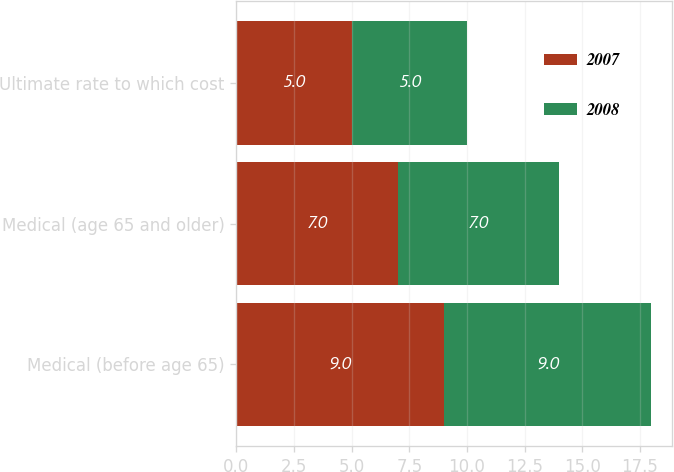Convert chart. <chart><loc_0><loc_0><loc_500><loc_500><stacked_bar_chart><ecel><fcel>Medical (before age 65)<fcel>Medical (age 65 and older)<fcel>Ultimate rate to which cost<nl><fcel>2007<fcel>9<fcel>7<fcel>5<nl><fcel>2008<fcel>9<fcel>7<fcel>5<nl></chart> 